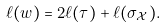<formula> <loc_0><loc_0><loc_500><loc_500>\ell ( w ) = 2 \ell ( \tau ) + \ell ( \sigma _ { \mathcal { X } } ) .</formula> 